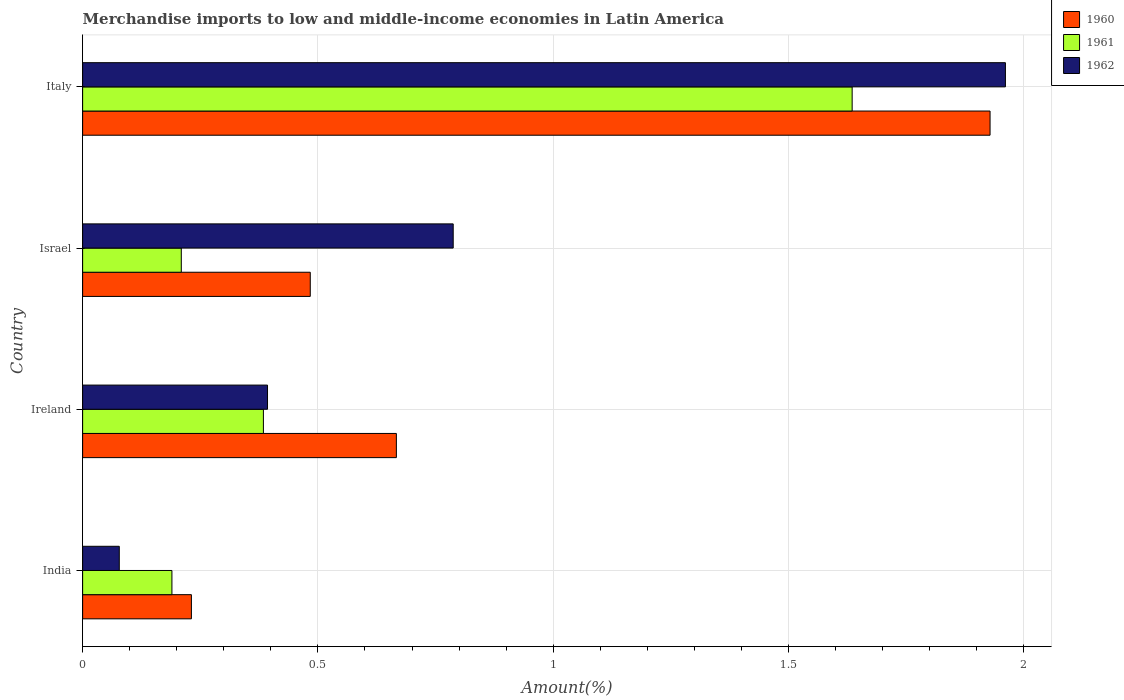How many different coloured bars are there?
Offer a very short reply. 3. How many groups of bars are there?
Offer a terse response. 4. Are the number of bars on each tick of the Y-axis equal?
Your answer should be compact. Yes. What is the label of the 2nd group of bars from the top?
Offer a very short reply. Israel. What is the percentage of amount earned from merchandise imports in 1960 in Ireland?
Make the answer very short. 0.67. Across all countries, what is the maximum percentage of amount earned from merchandise imports in 1960?
Your response must be concise. 1.93. Across all countries, what is the minimum percentage of amount earned from merchandise imports in 1960?
Your answer should be very brief. 0.23. What is the total percentage of amount earned from merchandise imports in 1962 in the graph?
Ensure brevity in your answer.  3.22. What is the difference between the percentage of amount earned from merchandise imports in 1960 in Ireland and that in Italy?
Make the answer very short. -1.26. What is the difference between the percentage of amount earned from merchandise imports in 1961 in Italy and the percentage of amount earned from merchandise imports in 1960 in Ireland?
Keep it short and to the point. 0.97. What is the average percentage of amount earned from merchandise imports in 1961 per country?
Provide a short and direct response. 0.6. What is the difference between the percentage of amount earned from merchandise imports in 1962 and percentage of amount earned from merchandise imports in 1961 in India?
Give a very brief answer. -0.11. What is the ratio of the percentage of amount earned from merchandise imports in 1961 in Ireland to that in Italy?
Provide a succinct answer. 0.23. Is the difference between the percentage of amount earned from merchandise imports in 1962 in India and Italy greater than the difference between the percentage of amount earned from merchandise imports in 1961 in India and Italy?
Ensure brevity in your answer.  No. What is the difference between the highest and the second highest percentage of amount earned from merchandise imports in 1962?
Make the answer very short. 1.17. What is the difference between the highest and the lowest percentage of amount earned from merchandise imports in 1960?
Offer a terse response. 1.7. In how many countries, is the percentage of amount earned from merchandise imports in 1961 greater than the average percentage of amount earned from merchandise imports in 1961 taken over all countries?
Your response must be concise. 1. What does the 2nd bar from the bottom in Italy represents?
Your response must be concise. 1961. How many bars are there?
Offer a very short reply. 12. Are all the bars in the graph horizontal?
Your response must be concise. Yes. How many countries are there in the graph?
Provide a succinct answer. 4. Are the values on the major ticks of X-axis written in scientific E-notation?
Provide a short and direct response. No. Does the graph contain grids?
Your answer should be very brief. Yes. How many legend labels are there?
Keep it short and to the point. 3. How are the legend labels stacked?
Your answer should be very brief. Vertical. What is the title of the graph?
Provide a short and direct response. Merchandise imports to low and middle-income economies in Latin America. What is the label or title of the X-axis?
Your response must be concise. Amount(%). What is the label or title of the Y-axis?
Provide a succinct answer. Country. What is the Amount(%) of 1960 in India?
Your answer should be very brief. 0.23. What is the Amount(%) of 1961 in India?
Ensure brevity in your answer.  0.19. What is the Amount(%) in 1962 in India?
Your response must be concise. 0.08. What is the Amount(%) of 1960 in Ireland?
Provide a short and direct response. 0.67. What is the Amount(%) in 1961 in Ireland?
Offer a very short reply. 0.38. What is the Amount(%) of 1962 in Ireland?
Your answer should be compact. 0.39. What is the Amount(%) in 1960 in Israel?
Offer a terse response. 0.48. What is the Amount(%) of 1961 in Israel?
Your answer should be very brief. 0.21. What is the Amount(%) in 1962 in Israel?
Give a very brief answer. 0.79. What is the Amount(%) of 1960 in Italy?
Provide a short and direct response. 1.93. What is the Amount(%) in 1961 in Italy?
Give a very brief answer. 1.64. What is the Amount(%) in 1962 in Italy?
Give a very brief answer. 1.96. Across all countries, what is the maximum Amount(%) in 1960?
Make the answer very short. 1.93. Across all countries, what is the maximum Amount(%) in 1961?
Make the answer very short. 1.64. Across all countries, what is the maximum Amount(%) of 1962?
Keep it short and to the point. 1.96. Across all countries, what is the minimum Amount(%) of 1960?
Your answer should be compact. 0.23. Across all countries, what is the minimum Amount(%) in 1961?
Your answer should be compact. 0.19. Across all countries, what is the minimum Amount(%) of 1962?
Your response must be concise. 0.08. What is the total Amount(%) in 1960 in the graph?
Offer a very short reply. 3.31. What is the total Amount(%) in 1961 in the graph?
Make the answer very short. 2.42. What is the total Amount(%) of 1962 in the graph?
Your answer should be very brief. 3.22. What is the difference between the Amount(%) of 1960 in India and that in Ireland?
Your answer should be compact. -0.44. What is the difference between the Amount(%) of 1961 in India and that in Ireland?
Provide a succinct answer. -0.19. What is the difference between the Amount(%) of 1962 in India and that in Ireland?
Your answer should be very brief. -0.32. What is the difference between the Amount(%) of 1960 in India and that in Israel?
Provide a succinct answer. -0.25. What is the difference between the Amount(%) in 1961 in India and that in Israel?
Your response must be concise. -0.02. What is the difference between the Amount(%) of 1962 in India and that in Israel?
Ensure brevity in your answer.  -0.71. What is the difference between the Amount(%) in 1960 in India and that in Italy?
Make the answer very short. -1.7. What is the difference between the Amount(%) in 1961 in India and that in Italy?
Give a very brief answer. -1.45. What is the difference between the Amount(%) in 1962 in India and that in Italy?
Offer a terse response. -1.88. What is the difference between the Amount(%) of 1960 in Ireland and that in Israel?
Make the answer very short. 0.18. What is the difference between the Amount(%) in 1961 in Ireland and that in Israel?
Provide a short and direct response. 0.17. What is the difference between the Amount(%) of 1962 in Ireland and that in Israel?
Your response must be concise. -0.39. What is the difference between the Amount(%) in 1960 in Ireland and that in Italy?
Offer a very short reply. -1.26. What is the difference between the Amount(%) of 1961 in Ireland and that in Italy?
Provide a succinct answer. -1.25. What is the difference between the Amount(%) in 1962 in Ireland and that in Italy?
Your answer should be very brief. -1.57. What is the difference between the Amount(%) of 1960 in Israel and that in Italy?
Provide a succinct answer. -1.44. What is the difference between the Amount(%) in 1961 in Israel and that in Italy?
Provide a succinct answer. -1.43. What is the difference between the Amount(%) of 1962 in Israel and that in Italy?
Offer a terse response. -1.17. What is the difference between the Amount(%) of 1960 in India and the Amount(%) of 1961 in Ireland?
Give a very brief answer. -0.15. What is the difference between the Amount(%) of 1960 in India and the Amount(%) of 1962 in Ireland?
Your answer should be compact. -0.16. What is the difference between the Amount(%) in 1961 in India and the Amount(%) in 1962 in Ireland?
Your answer should be compact. -0.2. What is the difference between the Amount(%) of 1960 in India and the Amount(%) of 1961 in Israel?
Your answer should be compact. 0.02. What is the difference between the Amount(%) of 1960 in India and the Amount(%) of 1962 in Israel?
Offer a very short reply. -0.56. What is the difference between the Amount(%) in 1961 in India and the Amount(%) in 1962 in Israel?
Your answer should be very brief. -0.6. What is the difference between the Amount(%) of 1960 in India and the Amount(%) of 1961 in Italy?
Your answer should be compact. -1.4. What is the difference between the Amount(%) in 1960 in India and the Amount(%) in 1962 in Italy?
Provide a succinct answer. -1.73. What is the difference between the Amount(%) of 1961 in India and the Amount(%) of 1962 in Italy?
Give a very brief answer. -1.77. What is the difference between the Amount(%) in 1960 in Ireland and the Amount(%) in 1961 in Israel?
Offer a terse response. 0.46. What is the difference between the Amount(%) in 1960 in Ireland and the Amount(%) in 1962 in Israel?
Give a very brief answer. -0.12. What is the difference between the Amount(%) in 1961 in Ireland and the Amount(%) in 1962 in Israel?
Ensure brevity in your answer.  -0.4. What is the difference between the Amount(%) of 1960 in Ireland and the Amount(%) of 1961 in Italy?
Offer a very short reply. -0.97. What is the difference between the Amount(%) of 1960 in Ireland and the Amount(%) of 1962 in Italy?
Keep it short and to the point. -1.29. What is the difference between the Amount(%) in 1961 in Ireland and the Amount(%) in 1962 in Italy?
Offer a very short reply. -1.58. What is the difference between the Amount(%) in 1960 in Israel and the Amount(%) in 1961 in Italy?
Keep it short and to the point. -1.15. What is the difference between the Amount(%) in 1960 in Israel and the Amount(%) in 1962 in Italy?
Make the answer very short. -1.48. What is the difference between the Amount(%) of 1961 in Israel and the Amount(%) of 1962 in Italy?
Offer a terse response. -1.75. What is the average Amount(%) of 1960 per country?
Keep it short and to the point. 0.83. What is the average Amount(%) of 1961 per country?
Offer a terse response. 0.6. What is the average Amount(%) in 1962 per country?
Your answer should be compact. 0.8. What is the difference between the Amount(%) in 1960 and Amount(%) in 1961 in India?
Your answer should be very brief. 0.04. What is the difference between the Amount(%) in 1960 and Amount(%) in 1962 in India?
Keep it short and to the point. 0.15. What is the difference between the Amount(%) in 1961 and Amount(%) in 1962 in India?
Ensure brevity in your answer.  0.11. What is the difference between the Amount(%) of 1960 and Amount(%) of 1961 in Ireland?
Ensure brevity in your answer.  0.28. What is the difference between the Amount(%) of 1960 and Amount(%) of 1962 in Ireland?
Your answer should be very brief. 0.27. What is the difference between the Amount(%) of 1961 and Amount(%) of 1962 in Ireland?
Give a very brief answer. -0.01. What is the difference between the Amount(%) in 1960 and Amount(%) in 1961 in Israel?
Keep it short and to the point. 0.27. What is the difference between the Amount(%) in 1960 and Amount(%) in 1962 in Israel?
Keep it short and to the point. -0.3. What is the difference between the Amount(%) in 1961 and Amount(%) in 1962 in Israel?
Offer a very short reply. -0.58. What is the difference between the Amount(%) of 1960 and Amount(%) of 1961 in Italy?
Provide a succinct answer. 0.29. What is the difference between the Amount(%) in 1960 and Amount(%) in 1962 in Italy?
Ensure brevity in your answer.  -0.03. What is the difference between the Amount(%) of 1961 and Amount(%) of 1962 in Italy?
Ensure brevity in your answer.  -0.33. What is the ratio of the Amount(%) in 1960 in India to that in Ireland?
Provide a short and direct response. 0.35. What is the ratio of the Amount(%) in 1961 in India to that in Ireland?
Your answer should be very brief. 0.49. What is the ratio of the Amount(%) in 1962 in India to that in Ireland?
Provide a succinct answer. 0.2. What is the ratio of the Amount(%) of 1960 in India to that in Israel?
Your response must be concise. 0.48. What is the ratio of the Amount(%) in 1961 in India to that in Israel?
Keep it short and to the point. 0.91. What is the ratio of the Amount(%) of 1962 in India to that in Israel?
Offer a very short reply. 0.1. What is the ratio of the Amount(%) in 1960 in India to that in Italy?
Provide a short and direct response. 0.12. What is the ratio of the Amount(%) in 1961 in India to that in Italy?
Offer a terse response. 0.12. What is the ratio of the Amount(%) in 1962 in India to that in Italy?
Your answer should be very brief. 0.04. What is the ratio of the Amount(%) of 1960 in Ireland to that in Israel?
Your answer should be compact. 1.38. What is the ratio of the Amount(%) in 1961 in Ireland to that in Israel?
Provide a short and direct response. 1.83. What is the ratio of the Amount(%) in 1962 in Ireland to that in Israel?
Your answer should be very brief. 0.5. What is the ratio of the Amount(%) of 1960 in Ireland to that in Italy?
Provide a short and direct response. 0.35. What is the ratio of the Amount(%) of 1961 in Ireland to that in Italy?
Keep it short and to the point. 0.23. What is the ratio of the Amount(%) of 1962 in Ireland to that in Italy?
Provide a short and direct response. 0.2. What is the ratio of the Amount(%) of 1960 in Israel to that in Italy?
Your response must be concise. 0.25. What is the ratio of the Amount(%) in 1961 in Israel to that in Italy?
Your response must be concise. 0.13. What is the ratio of the Amount(%) of 1962 in Israel to that in Italy?
Offer a terse response. 0.4. What is the difference between the highest and the second highest Amount(%) of 1960?
Provide a short and direct response. 1.26. What is the difference between the highest and the second highest Amount(%) in 1961?
Your answer should be compact. 1.25. What is the difference between the highest and the second highest Amount(%) in 1962?
Offer a very short reply. 1.17. What is the difference between the highest and the lowest Amount(%) in 1960?
Provide a succinct answer. 1.7. What is the difference between the highest and the lowest Amount(%) of 1961?
Keep it short and to the point. 1.45. What is the difference between the highest and the lowest Amount(%) in 1962?
Your answer should be very brief. 1.88. 